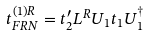Convert formula to latex. <formula><loc_0><loc_0><loc_500><loc_500>t _ { F R N } ^ { ( 1 ) R } = t _ { 2 } ^ { \prime } L ^ { R } U _ { 1 } t _ { 1 } U _ { 1 } ^ { \dagger }</formula> 